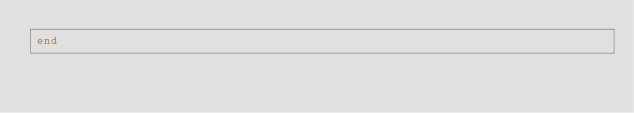Convert code to text. <code><loc_0><loc_0><loc_500><loc_500><_Elixir_>end
</code> 